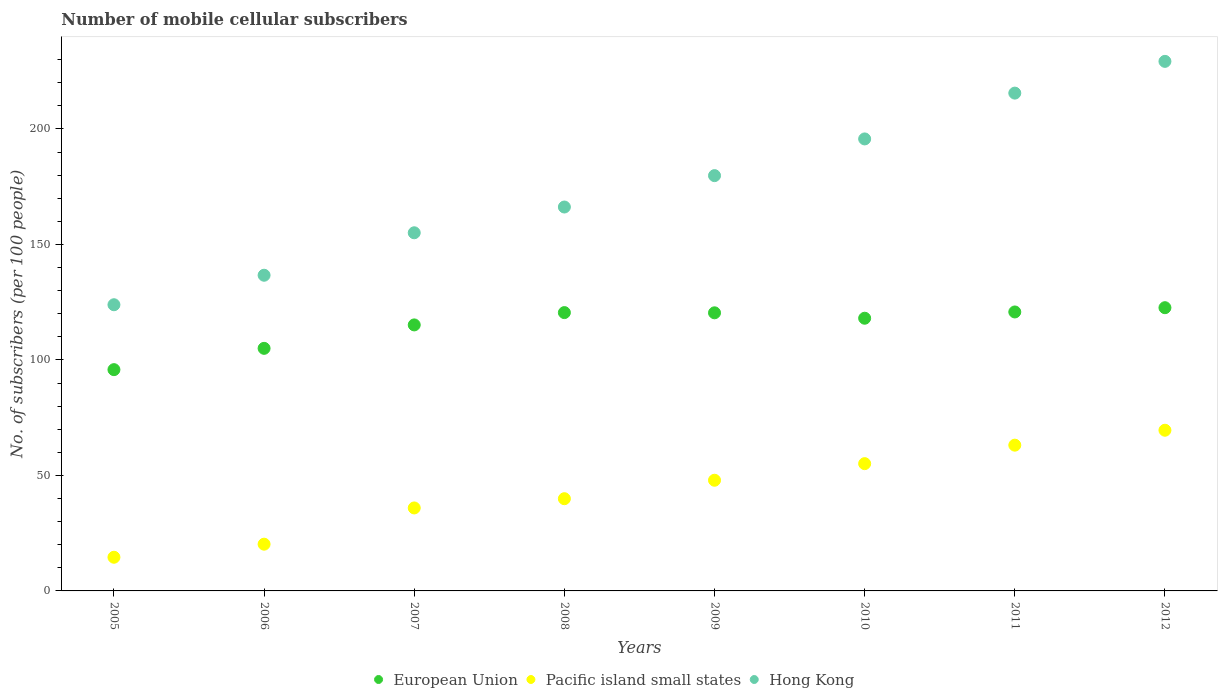Is the number of dotlines equal to the number of legend labels?
Keep it short and to the point. Yes. What is the number of mobile cellular subscribers in European Union in 2005?
Give a very brief answer. 95.79. Across all years, what is the maximum number of mobile cellular subscribers in Hong Kong?
Provide a succinct answer. 229.24. Across all years, what is the minimum number of mobile cellular subscribers in Hong Kong?
Make the answer very short. 123.89. In which year was the number of mobile cellular subscribers in Hong Kong maximum?
Provide a succinct answer. 2012. What is the total number of mobile cellular subscribers in Pacific island small states in the graph?
Ensure brevity in your answer.  346.33. What is the difference between the number of mobile cellular subscribers in Pacific island small states in 2005 and that in 2012?
Your answer should be compact. -54.99. What is the difference between the number of mobile cellular subscribers in European Union in 2008 and the number of mobile cellular subscribers in Pacific island small states in 2007?
Give a very brief answer. 84.56. What is the average number of mobile cellular subscribers in Hong Kong per year?
Make the answer very short. 175.25. In the year 2008, what is the difference between the number of mobile cellular subscribers in European Union and number of mobile cellular subscribers in Hong Kong?
Your answer should be very brief. -45.71. In how many years, is the number of mobile cellular subscribers in Pacific island small states greater than 210?
Ensure brevity in your answer.  0. What is the ratio of the number of mobile cellular subscribers in Hong Kong in 2008 to that in 2010?
Offer a very short reply. 0.85. Is the number of mobile cellular subscribers in European Union in 2006 less than that in 2012?
Offer a terse response. Yes. Is the difference between the number of mobile cellular subscribers in European Union in 2009 and 2012 greater than the difference between the number of mobile cellular subscribers in Hong Kong in 2009 and 2012?
Your answer should be very brief. Yes. What is the difference between the highest and the second highest number of mobile cellular subscribers in Pacific island small states?
Offer a very short reply. 6.46. What is the difference between the highest and the lowest number of mobile cellular subscribers in Hong Kong?
Keep it short and to the point. 105.36. In how many years, is the number of mobile cellular subscribers in European Union greater than the average number of mobile cellular subscribers in European Union taken over all years?
Provide a succinct answer. 6. Is the sum of the number of mobile cellular subscribers in Hong Kong in 2006 and 2008 greater than the maximum number of mobile cellular subscribers in Pacific island small states across all years?
Keep it short and to the point. Yes. Is the number of mobile cellular subscribers in Pacific island small states strictly less than the number of mobile cellular subscribers in European Union over the years?
Keep it short and to the point. Yes. How many dotlines are there?
Give a very brief answer. 3. What is the difference between two consecutive major ticks on the Y-axis?
Keep it short and to the point. 50. Does the graph contain grids?
Your answer should be very brief. No. Where does the legend appear in the graph?
Offer a very short reply. Bottom center. How many legend labels are there?
Provide a short and direct response. 3. How are the legend labels stacked?
Provide a succinct answer. Horizontal. What is the title of the graph?
Your answer should be compact. Number of mobile cellular subscribers. What is the label or title of the X-axis?
Keep it short and to the point. Years. What is the label or title of the Y-axis?
Provide a short and direct response. No. of subscribers (per 100 people). What is the No. of subscribers (per 100 people) of European Union in 2005?
Your answer should be very brief. 95.79. What is the No. of subscribers (per 100 people) of Pacific island small states in 2005?
Offer a terse response. 14.58. What is the No. of subscribers (per 100 people) in Hong Kong in 2005?
Provide a short and direct response. 123.89. What is the No. of subscribers (per 100 people) in European Union in 2006?
Your answer should be very brief. 105.01. What is the No. of subscribers (per 100 people) in Pacific island small states in 2006?
Give a very brief answer. 20.23. What is the No. of subscribers (per 100 people) of Hong Kong in 2006?
Provide a succinct answer. 136.66. What is the No. of subscribers (per 100 people) of European Union in 2007?
Your response must be concise. 115.16. What is the No. of subscribers (per 100 people) of Pacific island small states in 2007?
Your answer should be very brief. 35.92. What is the No. of subscribers (per 100 people) in Hong Kong in 2007?
Provide a succinct answer. 155.04. What is the No. of subscribers (per 100 people) in European Union in 2008?
Ensure brevity in your answer.  120.48. What is the No. of subscribers (per 100 people) in Pacific island small states in 2008?
Make the answer very short. 39.92. What is the No. of subscribers (per 100 people) of Hong Kong in 2008?
Your answer should be compact. 166.19. What is the No. of subscribers (per 100 people) in European Union in 2009?
Ensure brevity in your answer.  120.39. What is the No. of subscribers (per 100 people) in Pacific island small states in 2009?
Ensure brevity in your answer.  47.92. What is the No. of subscribers (per 100 people) of Hong Kong in 2009?
Your answer should be compact. 179.78. What is the No. of subscribers (per 100 people) in European Union in 2010?
Keep it short and to the point. 118.05. What is the No. of subscribers (per 100 people) of Pacific island small states in 2010?
Give a very brief answer. 55.1. What is the No. of subscribers (per 100 people) of Hong Kong in 2010?
Your response must be concise. 195.67. What is the No. of subscribers (per 100 people) in European Union in 2011?
Ensure brevity in your answer.  120.76. What is the No. of subscribers (per 100 people) in Pacific island small states in 2011?
Keep it short and to the point. 63.1. What is the No. of subscribers (per 100 people) in Hong Kong in 2011?
Make the answer very short. 215.5. What is the No. of subscribers (per 100 people) in European Union in 2012?
Your response must be concise. 122.61. What is the No. of subscribers (per 100 people) of Pacific island small states in 2012?
Provide a succinct answer. 69.56. What is the No. of subscribers (per 100 people) of Hong Kong in 2012?
Ensure brevity in your answer.  229.24. Across all years, what is the maximum No. of subscribers (per 100 people) in European Union?
Provide a succinct answer. 122.61. Across all years, what is the maximum No. of subscribers (per 100 people) of Pacific island small states?
Provide a succinct answer. 69.56. Across all years, what is the maximum No. of subscribers (per 100 people) in Hong Kong?
Give a very brief answer. 229.24. Across all years, what is the minimum No. of subscribers (per 100 people) in European Union?
Provide a short and direct response. 95.79. Across all years, what is the minimum No. of subscribers (per 100 people) in Pacific island small states?
Ensure brevity in your answer.  14.58. Across all years, what is the minimum No. of subscribers (per 100 people) in Hong Kong?
Ensure brevity in your answer.  123.89. What is the total No. of subscribers (per 100 people) of European Union in the graph?
Give a very brief answer. 918.26. What is the total No. of subscribers (per 100 people) in Pacific island small states in the graph?
Your answer should be very brief. 346.33. What is the total No. of subscribers (per 100 people) in Hong Kong in the graph?
Offer a very short reply. 1401.98. What is the difference between the No. of subscribers (per 100 people) in European Union in 2005 and that in 2006?
Provide a short and direct response. -9.22. What is the difference between the No. of subscribers (per 100 people) of Pacific island small states in 2005 and that in 2006?
Offer a very short reply. -5.66. What is the difference between the No. of subscribers (per 100 people) of Hong Kong in 2005 and that in 2006?
Make the answer very short. -12.77. What is the difference between the No. of subscribers (per 100 people) of European Union in 2005 and that in 2007?
Provide a short and direct response. -19.36. What is the difference between the No. of subscribers (per 100 people) in Pacific island small states in 2005 and that in 2007?
Keep it short and to the point. -21.35. What is the difference between the No. of subscribers (per 100 people) in Hong Kong in 2005 and that in 2007?
Make the answer very short. -31.15. What is the difference between the No. of subscribers (per 100 people) in European Union in 2005 and that in 2008?
Provide a short and direct response. -24.69. What is the difference between the No. of subscribers (per 100 people) of Pacific island small states in 2005 and that in 2008?
Your answer should be compact. -25.35. What is the difference between the No. of subscribers (per 100 people) in Hong Kong in 2005 and that in 2008?
Make the answer very short. -42.3. What is the difference between the No. of subscribers (per 100 people) of European Union in 2005 and that in 2009?
Offer a very short reply. -24.6. What is the difference between the No. of subscribers (per 100 people) in Pacific island small states in 2005 and that in 2009?
Offer a terse response. -33.34. What is the difference between the No. of subscribers (per 100 people) of Hong Kong in 2005 and that in 2009?
Make the answer very short. -55.89. What is the difference between the No. of subscribers (per 100 people) in European Union in 2005 and that in 2010?
Your answer should be compact. -22.26. What is the difference between the No. of subscribers (per 100 people) of Pacific island small states in 2005 and that in 2010?
Your answer should be compact. -40.52. What is the difference between the No. of subscribers (per 100 people) in Hong Kong in 2005 and that in 2010?
Your response must be concise. -71.78. What is the difference between the No. of subscribers (per 100 people) of European Union in 2005 and that in 2011?
Offer a terse response. -24.97. What is the difference between the No. of subscribers (per 100 people) in Pacific island small states in 2005 and that in 2011?
Your answer should be compact. -48.53. What is the difference between the No. of subscribers (per 100 people) of Hong Kong in 2005 and that in 2011?
Your answer should be very brief. -91.61. What is the difference between the No. of subscribers (per 100 people) in European Union in 2005 and that in 2012?
Offer a very short reply. -26.82. What is the difference between the No. of subscribers (per 100 people) of Pacific island small states in 2005 and that in 2012?
Your answer should be compact. -54.99. What is the difference between the No. of subscribers (per 100 people) in Hong Kong in 2005 and that in 2012?
Your response must be concise. -105.36. What is the difference between the No. of subscribers (per 100 people) in European Union in 2006 and that in 2007?
Offer a terse response. -10.14. What is the difference between the No. of subscribers (per 100 people) in Pacific island small states in 2006 and that in 2007?
Offer a very short reply. -15.69. What is the difference between the No. of subscribers (per 100 people) in Hong Kong in 2006 and that in 2007?
Provide a short and direct response. -18.38. What is the difference between the No. of subscribers (per 100 people) of European Union in 2006 and that in 2008?
Keep it short and to the point. -15.47. What is the difference between the No. of subscribers (per 100 people) of Pacific island small states in 2006 and that in 2008?
Give a very brief answer. -19.69. What is the difference between the No. of subscribers (per 100 people) of Hong Kong in 2006 and that in 2008?
Keep it short and to the point. -29.53. What is the difference between the No. of subscribers (per 100 people) in European Union in 2006 and that in 2009?
Offer a very short reply. -15.38. What is the difference between the No. of subscribers (per 100 people) in Pacific island small states in 2006 and that in 2009?
Offer a very short reply. -27.68. What is the difference between the No. of subscribers (per 100 people) of Hong Kong in 2006 and that in 2009?
Make the answer very short. -43.12. What is the difference between the No. of subscribers (per 100 people) of European Union in 2006 and that in 2010?
Give a very brief answer. -13.04. What is the difference between the No. of subscribers (per 100 people) of Pacific island small states in 2006 and that in 2010?
Keep it short and to the point. -34.86. What is the difference between the No. of subscribers (per 100 people) of Hong Kong in 2006 and that in 2010?
Make the answer very short. -59.01. What is the difference between the No. of subscribers (per 100 people) in European Union in 2006 and that in 2011?
Keep it short and to the point. -15.75. What is the difference between the No. of subscribers (per 100 people) in Pacific island small states in 2006 and that in 2011?
Ensure brevity in your answer.  -42.87. What is the difference between the No. of subscribers (per 100 people) in Hong Kong in 2006 and that in 2011?
Make the answer very short. -78.84. What is the difference between the No. of subscribers (per 100 people) of European Union in 2006 and that in 2012?
Your answer should be compact. -17.6. What is the difference between the No. of subscribers (per 100 people) of Pacific island small states in 2006 and that in 2012?
Provide a short and direct response. -49.33. What is the difference between the No. of subscribers (per 100 people) of Hong Kong in 2006 and that in 2012?
Provide a succinct answer. -92.58. What is the difference between the No. of subscribers (per 100 people) of European Union in 2007 and that in 2008?
Your answer should be very brief. -5.33. What is the difference between the No. of subscribers (per 100 people) in Pacific island small states in 2007 and that in 2008?
Make the answer very short. -4. What is the difference between the No. of subscribers (per 100 people) in Hong Kong in 2007 and that in 2008?
Your answer should be compact. -11.15. What is the difference between the No. of subscribers (per 100 people) in European Union in 2007 and that in 2009?
Your response must be concise. -5.24. What is the difference between the No. of subscribers (per 100 people) of Pacific island small states in 2007 and that in 2009?
Keep it short and to the point. -11.99. What is the difference between the No. of subscribers (per 100 people) in Hong Kong in 2007 and that in 2009?
Provide a succinct answer. -24.74. What is the difference between the No. of subscribers (per 100 people) of European Union in 2007 and that in 2010?
Keep it short and to the point. -2.89. What is the difference between the No. of subscribers (per 100 people) in Pacific island small states in 2007 and that in 2010?
Your answer should be very brief. -19.18. What is the difference between the No. of subscribers (per 100 people) in Hong Kong in 2007 and that in 2010?
Offer a very short reply. -40.63. What is the difference between the No. of subscribers (per 100 people) of European Union in 2007 and that in 2011?
Your answer should be compact. -5.61. What is the difference between the No. of subscribers (per 100 people) of Pacific island small states in 2007 and that in 2011?
Ensure brevity in your answer.  -27.18. What is the difference between the No. of subscribers (per 100 people) of Hong Kong in 2007 and that in 2011?
Provide a short and direct response. -60.46. What is the difference between the No. of subscribers (per 100 people) of European Union in 2007 and that in 2012?
Your answer should be very brief. -7.45. What is the difference between the No. of subscribers (per 100 people) in Pacific island small states in 2007 and that in 2012?
Offer a very short reply. -33.64. What is the difference between the No. of subscribers (per 100 people) of Hong Kong in 2007 and that in 2012?
Offer a very short reply. -74.2. What is the difference between the No. of subscribers (per 100 people) in European Union in 2008 and that in 2009?
Offer a very short reply. 0.09. What is the difference between the No. of subscribers (per 100 people) of Pacific island small states in 2008 and that in 2009?
Provide a succinct answer. -7.99. What is the difference between the No. of subscribers (per 100 people) in Hong Kong in 2008 and that in 2009?
Make the answer very short. -13.59. What is the difference between the No. of subscribers (per 100 people) in European Union in 2008 and that in 2010?
Make the answer very short. 2.44. What is the difference between the No. of subscribers (per 100 people) in Pacific island small states in 2008 and that in 2010?
Your answer should be compact. -15.18. What is the difference between the No. of subscribers (per 100 people) in Hong Kong in 2008 and that in 2010?
Keep it short and to the point. -29.48. What is the difference between the No. of subscribers (per 100 people) in European Union in 2008 and that in 2011?
Make the answer very short. -0.28. What is the difference between the No. of subscribers (per 100 people) in Pacific island small states in 2008 and that in 2011?
Ensure brevity in your answer.  -23.18. What is the difference between the No. of subscribers (per 100 people) in Hong Kong in 2008 and that in 2011?
Ensure brevity in your answer.  -49.31. What is the difference between the No. of subscribers (per 100 people) in European Union in 2008 and that in 2012?
Give a very brief answer. -2.13. What is the difference between the No. of subscribers (per 100 people) of Pacific island small states in 2008 and that in 2012?
Offer a terse response. -29.64. What is the difference between the No. of subscribers (per 100 people) of Hong Kong in 2008 and that in 2012?
Your answer should be very brief. -63.05. What is the difference between the No. of subscribers (per 100 people) of European Union in 2009 and that in 2010?
Give a very brief answer. 2.34. What is the difference between the No. of subscribers (per 100 people) in Pacific island small states in 2009 and that in 2010?
Keep it short and to the point. -7.18. What is the difference between the No. of subscribers (per 100 people) of Hong Kong in 2009 and that in 2010?
Offer a very short reply. -15.89. What is the difference between the No. of subscribers (per 100 people) in European Union in 2009 and that in 2011?
Give a very brief answer. -0.37. What is the difference between the No. of subscribers (per 100 people) in Pacific island small states in 2009 and that in 2011?
Ensure brevity in your answer.  -15.19. What is the difference between the No. of subscribers (per 100 people) in Hong Kong in 2009 and that in 2011?
Provide a short and direct response. -35.72. What is the difference between the No. of subscribers (per 100 people) in European Union in 2009 and that in 2012?
Your answer should be very brief. -2.22. What is the difference between the No. of subscribers (per 100 people) in Pacific island small states in 2009 and that in 2012?
Your response must be concise. -21.65. What is the difference between the No. of subscribers (per 100 people) in Hong Kong in 2009 and that in 2012?
Keep it short and to the point. -49.46. What is the difference between the No. of subscribers (per 100 people) of European Union in 2010 and that in 2011?
Make the answer very short. -2.72. What is the difference between the No. of subscribers (per 100 people) in Pacific island small states in 2010 and that in 2011?
Give a very brief answer. -8. What is the difference between the No. of subscribers (per 100 people) of Hong Kong in 2010 and that in 2011?
Offer a very short reply. -19.83. What is the difference between the No. of subscribers (per 100 people) of European Union in 2010 and that in 2012?
Offer a terse response. -4.56. What is the difference between the No. of subscribers (per 100 people) in Pacific island small states in 2010 and that in 2012?
Your response must be concise. -14.46. What is the difference between the No. of subscribers (per 100 people) of Hong Kong in 2010 and that in 2012?
Your answer should be compact. -33.58. What is the difference between the No. of subscribers (per 100 people) in European Union in 2011 and that in 2012?
Ensure brevity in your answer.  -1.85. What is the difference between the No. of subscribers (per 100 people) of Pacific island small states in 2011 and that in 2012?
Ensure brevity in your answer.  -6.46. What is the difference between the No. of subscribers (per 100 people) in Hong Kong in 2011 and that in 2012?
Keep it short and to the point. -13.74. What is the difference between the No. of subscribers (per 100 people) of European Union in 2005 and the No. of subscribers (per 100 people) of Pacific island small states in 2006?
Keep it short and to the point. 75.56. What is the difference between the No. of subscribers (per 100 people) in European Union in 2005 and the No. of subscribers (per 100 people) in Hong Kong in 2006?
Your answer should be compact. -40.87. What is the difference between the No. of subscribers (per 100 people) in Pacific island small states in 2005 and the No. of subscribers (per 100 people) in Hong Kong in 2006?
Give a very brief answer. -122.08. What is the difference between the No. of subscribers (per 100 people) in European Union in 2005 and the No. of subscribers (per 100 people) in Pacific island small states in 2007?
Provide a succinct answer. 59.87. What is the difference between the No. of subscribers (per 100 people) of European Union in 2005 and the No. of subscribers (per 100 people) of Hong Kong in 2007?
Provide a succinct answer. -59.25. What is the difference between the No. of subscribers (per 100 people) of Pacific island small states in 2005 and the No. of subscribers (per 100 people) of Hong Kong in 2007?
Keep it short and to the point. -140.46. What is the difference between the No. of subscribers (per 100 people) of European Union in 2005 and the No. of subscribers (per 100 people) of Pacific island small states in 2008?
Offer a terse response. 55.87. What is the difference between the No. of subscribers (per 100 people) in European Union in 2005 and the No. of subscribers (per 100 people) in Hong Kong in 2008?
Your answer should be very brief. -70.4. What is the difference between the No. of subscribers (per 100 people) in Pacific island small states in 2005 and the No. of subscribers (per 100 people) in Hong Kong in 2008?
Provide a short and direct response. -151.62. What is the difference between the No. of subscribers (per 100 people) in European Union in 2005 and the No. of subscribers (per 100 people) in Pacific island small states in 2009?
Offer a very short reply. 47.88. What is the difference between the No. of subscribers (per 100 people) of European Union in 2005 and the No. of subscribers (per 100 people) of Hong Kong in 2009?
Your answer should be compact. -83.99. What is the difference between the No. of subscribers (per 100 people) of Pacific island small states in 2005 and the No. of subscribers (per 100 people) of Hong Kong in 2009?
Your answer should be compact. -165.21. What is the difference between the No. of subscribers (per 100 people) in European Union in 2005 and the No. of subscribers (per 100 people) in Pacific island small states in 2010?
Provide a succinct answer. 40.69. What is the difference between the No. of subscribers (per 100 people) in European Union in 2005 and the No. of subscribers (per 100 people) in Hong Kong in 2010?
Offer a very short reply. -99.88. What is the difference between the No. of subscribers (per 100 people) of Pacific island small states in 2005 and the No. of subscribers (per 100 people) of Hong Kong in 2010?
Your answer should be very brief. -181.09. What is the difference between the No. of subscribers (per 100 people) in European Union in 2005 and the No. of subscribers (per 100 people) in Pacific island small states in 2011?
Your answer should be very brief. 32.69. What is the difference between the No. of subscribers (per 100 people) in European Union in 2005 and the No. of subscribers (per 100 people) in Hong Kong in 2011?
Ensure brevity in your answer.  -119.71. What is the difference between the No. of subscribers (per 100 people) of Pacific island small states in 2005 and the No. of subscribers (per 100 people) of Hong Kong in 2011?
Your answer should be compact. -200.93. What is the difference between the No. of subscribers (per 100 people) in European Union in 2005 and the No. of subscribers (per 100 people) in Pacific island small states in 2012?
Give a very brief answer. 26.23. What is the difference between the No. of subscribers (per 100 people) of European Union in 2005 and the No. of subscribers (per 100 people) of Hong Kong in 2012?
Provide a short and direct response. -133.45. What is the difference between the No. of subscribers (per 100 people) of Pacific island small states in 2005 and the No. of subscribers (per 100 people) of Hong Kong in 2012?
Provide a short and direct response. -214.67. What is the difference between the No. of subscribers (per 100 people) of European Union in 2006 and the No. of subscribers (per 100 people) of Pacific island small states in 2007?
Keep it short and to the point. 69.09. What is the difference between the No. of subscribers (per 100 people) in European Union in 2006 and the No. of subscribers (per 100 people) in Hong Kong in 2007?
Provide a succinct answer. -50.03. What is the difference between the No. of subscribers (per 100 people) in Pacific island small states in 2006 and the No. of subscribers (per 100 people) in Hong Kong in 2007?
Your response must be concise. -134.81. What is the difference between the No. of subscribers (per 100 people) in European Union in 2006 and the No. of subscribers (per 100 people) in Pacific island small states in 2008?
Ensure brevity in your answer.  65.09. What is the difference between the No. of subscribers (per 100 people) in European Union in 2006 and the No. of subscribers (per 100 people) in Hong Kong in 2008?
Offer a terse response. -61.18. What is the difference between the No. of subscribers (per 100 people) in Pacific island small states in 2006 and the No. of subscribers (per 100 people) in Hong Kong in 2008?
Offer a terse response. -145.96. What is the difference between the No. of subscribers (per 100 people) in European Union in 2006 and the No. of subscribers (per 100 people) in Pacific island small states in 2009?
Offer a very short reply. 57.1. What is the difference between the No. of subscribers (per 100 people) in European Union in 2006 and the No. of subscribers (per 100 people) in Hong Kong in 2009?
Offer a terse response. -74.77. What is the difference between the No. of subscribers (per 100 people) in Pacific island small states in 2006 and the No. of subscribers (per 100 people) in Hong Kong in 2009?
Make the answer very short. -159.55. What is the difference between the No. of subscribers (per 100 people) of European Union in 2006 and the No. of subscribers (per 100 people) of Pacific island small states in 2010?
Give a very brief answer. 49.92. What is the difference between the No. of subscribers (per 100 people) in European Union in 2006 and the No. of subscribers (per 100 people) in Hong Kong in 2010?
Provide a short and direct response. -90.66. What is the difference between the No. of subscribers (per 100 people) in Pacific island small states in 2006 and the No. of subscribers (per 100 people) in Hong Kong in 2010?
Offer a very short reply. -175.43. What is the difference between the No. of subscribers (per 100 people) of European Union in 2006 and the No. of subscribers (per 100 people) of Pacific island small states in 2011?
Your answer should be very brief. 41.91. What is the difference between the No. of subscribers (per 100 people) of European Union in 2006 and the No. of subscribers (per 100 people) of Hong Kong in 2011?
Provide a short and direct response. -110.49. What is the difference between the No. of subscribers (per 100 people) in Pacific island small states in 2006 and the No. of subscribers (per 100 people) in Hong Kong in 2011?
Your response must be concise. -195.27. What is the difference between the No. of subscribers (per 100 people) of European Union in 2006 and the No. of subscribers (per 100 people) of Pacific island small states in 2012?
Provide a succinct answer. 35.45. What is the difference between the No. of subscribers (per 100 people) in European Union in 2006 and the No. of subscribers (per 100 people) in Hong Kong in 2012?
Offer a terse response. -124.23. What is the difference between the No. of subscribers (per 100 people) in Pacific island small states in 2006 and the No. of subscribers (per 100 people) in Hong Kong in 2012?
Ensure brevity in your answer.  -209.01. What is the difference between the No. of subscribers (per 100 people) of European Union in 2007 and the No. of subscribers (per 100 people) of Pacific island small states in 2008?
Your answer should be very brief. 75.23. What is the difference between the No. of subscribers (per 100 people) in European Union in 2007 and the No. of subscribers (per 100 people) in Hong Kong in 2008?
Your answer should be compact. -51.04. What is the difference between the No. of subscribers (per 100 people) of Pacific island small states in 2007 and the No. of subscribers (per 100 people) of Hong Kong in 2008?
Give a very brief answer. -130.27. What is the difference between the No. of subscribers (per 100 people) of European Union in 2007 and the No. of subscribers (per 100 people) of Pacific island small states in 2009?
Offer a terse response. 67.24. What is the difference between the No. of subscribers (per 100 people) in European Union in 2007 and the No. of subscribers (per 100 people) in Hong Kong in 2009?
Keep it short and to the point. -64.63. What is the difference between the No. of subscribers (per 100 people) in Pacific island small states in 2007 and the No. of subscribers (per 100 people) in Hong Kong in 2009?
Ensure brevity in your answer.  -143.86. What is the difference between the No. of subscribers (per 100 people) in European Union in 2007 and the No. of subscribers (per 100 people) in Pacific island small states in 2010?
Provide a succinct answer. 60.06. What is the difference between the No. of subscribers (per 100 people) of European Union in 2007 and the No. of subscribers (per 100 people) of Hong Kong in 2010?
Provide a succinct answer. -80.51. What is the difference between the No. of subscribers (per 100 people) in Pacific island small states in 2007 and the No. of subscribers (per 100 people) in Hong Kong in 2010?
Make the answer very short. -159.75. What is the difference between the No. of subscribers (per 100 people) of European Union in 2007 and the No. of subscribers (per 100 people) of Pacific island small states in 2011?
Provide a succinct answer. 52.06. What is the difference between the No. of subscribers (per 100 people) in European Union in 2007 and the No. of subscribers (per 100 people) in Hong Kong in 2011?
Provide a short and direct response. -100.35. What is the difference between the No. of subscribers (per 100 people) in Pacific island small states in 2007 and the No. of subscribers (per 100 people) in Hong Kong in 2011?
Keep it short and to the point. -179.58. What is the difference between the No. of subscribers (per 100 people) in European Union in 2007 and the No. of subscribers (per 100 people) in Pacific island small states in 2012?
Offer a very short reply. 45.59. What is the difference between the No. of subscribers (per 100 people) of European Union in 2007 and the No. of subscribers (per 100 people) of Hong Kong in 2012?
Your answer should be compact. -114.09. What is the difference between the No. of subscribers (per 100 people) of Pacific island small states in 2007 and the No. of subscribers (per 100 people) of Hong Kong in 2012?
Provide a succinct answer. -193.32. What is the difference between the No. of subscribers (per 100 people) in European Union in 2008 and the No. of subscribers (per 100 people) in Pacific island small states in 2009?
Your answer should be very brief. 72.57. What is the difference between the No. of subscribers (per 100 people) of European Union in 2008 and the No. of subscribers (per 100 people) of Hong Kong in 2009?
Make the answer very short. -59.3. What is the difference between the No. of subscribers (per 100 people) of Pacific island small states in 2008 and the No. of subscribers (per 100 people) of Hong Kong in 2009?
Your response must be concise. -139.86. What is the difference between the No. of subscribers (per 100 people) of European Union in 2008 and the No. of subscribers (per 100 people) of Pacific island small states in 2010?
Provide a short and direct response. 65.39. What is the difference between the No. of subscribers (per 100 people) of European Union in 2008 and the No. of subscribers (per 100 people) of Hong Kong in 2010?
Your response must be concise. -75.19. What is the difference between the No. of subscribers (per 100 people) in Pacific island small states in 2008 and the No. of subscribers (per 100 people) in Hong Kong in 2010?
Your answer should be very brief. -155.75. What is the difference between the No. of subscribers (per 100 people) of European Union in 2008 and the No. of subscribers (per 100 people) of Pacific island small states in 2011?
Give a very brief answer. 57.38. What is the difference between the No. of subscribers (per 100 people) in European Union in 2008 and the No. of subscribers (per 100 people) in Hong Kong in 2011?
Offer a very short reply. -95.02. What is the difference between the No. of subscribers (per 100 people) in Pacific island small states in 2008 and the No. of subscribers (per 100 people) in Hong Kong in 2011?
Offer a very short reply. -175.58. What is the difference between the No. of subscribers (per 100 people) in European Union in 2008 and the No. of subscribers (per 100 people) in Pacific island small states in 2012?
Make the answer very short. 50.92. What is the difference between the No. of subscribers (per 100 people) of European Union in 2008 and the No. of subscribers (per 100 people) of Hong Kong in 2012?
Provide a short and direct response. -108.76. What is the difference between the No. of subscribers (per 100 people) of Pacific island small states in 2008 and the No. of subscribers (per 100 people) of Hong Kong in 2012?
Keep it short and to the point. -189.32. What is the difference between the No. of subscribers (per 100 people) of European Union in 2009 and the No. of subscribers (per 100 people) of Pacific island small states in 2010?
Provide a short and direct response. 65.3. What is the difference between the No. of subscribers (per 100 people) in European Union in 2009 and the No. of subscribers (per 100 people) in Hong Kong in 2010?
Offer a terse response. -75.28. What is the difference between the No. of subscribers (per 100 people) of Pacific island small states in 2009 and the No. of subscribers (per 100 people) of Hong Kong in 2010?
Your answer should be compact. -147.75. What is the difference between the No. of subscribers (per 100 people) in European Union in 2009 and the No. of subscribers (per 100 people) in Pacific island small states in 2011?
Keep it short and to the point. 57.29. What is the difference between the No. of subscribers (per 100 people) of European Union in 2009 and the No. of subscribers (per 100 people) of Hong Kong in 2011?
Give a very brief answer. -95.11. What is the difference between the No. of subscribers (per 100 people) in Pacific island small states in 2009 and the No. of subscribers (per 100 people) in Hong Kong in 2011?
Provide a short and direct response. -167.59. What is the difference between the No. of subscribers (per 100 people) of European Union in 2009 and the No. of subscribers (per 100 people) of Pacific island small states in 2012?
Your response must be concise. 50.83. What is the difference between the No. of subscribers (per 100 people) in European Union in 2009 and the No. of subscribers (per 100 people) in Hong Kong in 2012?
Ensure brevity in your answer.  -108.85. What is the difference between the No. of subscribers (per 100 people) of Pacific island small states in 2009 and the No. of subscribers (per 100 people) of Hong Kong in 2012?
Provide a short and direct response. -181.33. What is the difference between the No. of subscribers (per 100 people) in European Union in 2010 and the No. of subscribers (per 100 people) in Pacific island small states in 2011?
Provide a short and direct response. 54.95. What is the difference between the No. of subscribers (per 100 people) in European Union in 2010 and the No. of subscribers (per 100 people) in Hong Kong in 2011?
Your answer should be compact. -97.46. What is the difference between the No. of subscribers (per 100 people) of Pacific island small states in 2010 and the No. of subscribers (per 100 people) of Hong Kong in 2011?
Offer a very short reply. -160.41. What is the difference between the No. of subscribers (per 100 people) in European Union in 2010 and the No. of subscribers (per 100 people) in Pacific island small states in 2012?
Make the answer very short. 48.49. What is the difference between the No. of subscribers (per 100 people) in European Union in 2010 and the No. of subscribers (per 100 people) in Hong Kong in 2012?
Provide a succinct answer. -111.2. What is the difference between the No. of subscribers (per 100 people) in Pacific island small states in 2010 and the No. of subscribers (per 100 people) in Hong Kong in 2012?
Provide a succinct answer. -174.15. What is the difference between the No. of subscribers (per 100 people) in European Union in 2011 and the No. of subscribers (per 100 people) in Pacific island small states in 2012?
Your answer should be very brief. 51.2. What is the difference between the No. of subscribers (per 100 people) of European Union in 2011 and the No. of subscribers (per 100 people) of Hong Kong in 2012?
Make the answer very short. -108.48. What is the difference between the No. of subscribers (per 100 people) in Pacific island small states in 2011 and the No. of subscribers (per 100 people) in Hong Kong in 2012?
Your response must be concise. -166.14. What is the average No. of subscribers (per 100 people) in European Union per year?
Keep it short and to the point. 114.78. What is the average No. of subscribers (per 100 people) of Pacific island small states per year?
Offer a terse response. 43.29. What is the average No. of subscribers (per 100 people) of Hong Kong per year?
Your response must be concise. 175.25. In the year 2005, what is the difference between the No. of subscribers (per 100 people) in European Union and No. of subscribers (per 100 people) in Pacific island small states?
Your answer should be very brief. 81.22. In the year 2005, what is the difference between the No. of subscribers (per 100 people) of European Union and No. of subscribers (per 100 people) of Hong Kong?
Your response must be concise. -28.1. In the year 2005, what is the difference between the No. of subscribers (per 100 people) of Pacific island small states and No. of subscribers (per 100 people) of Hong Kong?
Keep it short and to the point. -109.31. In the year 2006, what is the difference between the No. of subscribers (per 100 people) in European Union and No. of subscribers (per 100 people) in Pacific island small states?
Your response must be concise. 84.78. In the year 2006, what is the difference between the No. of subscribers (per 100 people) in European Union and No. of subscribers (per 100 people) in Hong Kong?
Provide a short and direct response. -31.65. In the year 2006, what is the difference between the No. of subscribers (per 100 people) in Pacific island small states and No. of subscribers (per 100 people) in Hong Kong?
Your response must be concise. -116.43. In the year 2007, what is the difference between the No. of subscribers (per 100 people) of European Union and No. of subscribers (per 100 people) of Pacific island small states?
Your answer should be very brief. 79.23. In the year 2007, what is the difference between the No. of subscribers (per 100 people) of European Union and No. of subscribers (per 100 people) of Hong Kong?
Provide a short and direct response. -39.88. In the year 2007, what is the difference between the No. of subscribers (per 100 people) in Pacific island small states and No. of subscribers (per 100 people) in Hong Kong?
Make the answer very short. -119.12. In the year 2008, what is the difference between the No. of subscribers (per 100 people) in European Union and No. of subscribers (per 100 people) in Pacific island small states?
Offer a very short reply. 80.56. In the year 2008, what is the difference between the No. of subscribers (per 100 people) of European Union and No. of subscribers (per 100 people) of Hong Kong?
Make the answer very short. -45.71. In the year 2008, what is the difference between the No. of subscribers (per 100 people) of Pacific island small states and No. of subscribers (per 100 people) of Hong Kong?
Make the answer very short. -126.27. In the year 2009, what is the difference between the No. of subscribers (per 100 people) of European Union and No. of subscribers (per 100 people) of Pacific island small states?
Your response must be concise. 72.48. In the year 2009, what is the difference between the No. of subscribers (per 100 people) of European Union and No. of subscribers (per 100 people) of Hong Kong?
Offer a terse response. -59.39. In the year 2009, what is the difference between the No. of subscribers (per 100 people) of Pacific island small states and No. of subscribers (per 100 people) of Hong Kong?
Offer a terse response. -131.87. In the year 2010, what is the difference between the No. of subscribers (per 100 people) of European Union and No. of subscribers (per 100 people) of Pacific island small states?
Keep it short and to the point. 62.95. In the year 2010, what is the difference between the No. of subscribers (per 100 people) in European Union and No. of subscribers (per 100 people) in Hong Kong?
Offer a very short reply. -77.62. In the year 2010, what is the difference between the No. of subscribers (per 100 people) of Pacific island small states and No. of subscribers (per 100 people) of Hong Kong?
Provide a succinct answer. -140.57. In the year 2011, what is the difference between the No. of subscribers (per 100 people) of European Union and No. of subscribers (per 100 people) of Pacific island small states?
Make the answer very short. 57.66. In the year 2011, what is the difference between the No. of subscribers (per 100 people) in European Union and No. of subscribers (per 100 people) in Hong Kong?
Ensure brevity in your answer.  -94.74. In the year 2011, what is the difference between the No. of subscribers (per 100 people) of Pacific island small states and No. of subscribers (per 100 people) of Hong Kong?
Your answer should be very brief. -152.4. In the year 2012, what is the difference between the No. of subscribers (per 100 people) in European Union and No. of subscribers (per 100 people) in Pacific island small states?
Provide a succinct answer. 53.05. In the year 2012, what is the difference between the No. of subscribers (per 100 people) in European Union and No. of subscribers (per 100 people) in Hong Kong?
Provide a short and direct response. -106.63. In the year 2012, what is the difference between the No. of subscribers (per 100 people) in Pacific island small states and No. of subscribers (per 100 people) in Hong Kong?
Offer a terse response. -159.68. What is the ratio of the No. of subscribers (per 100 people) of European Union in 2005 to that in 2006?
Keep it short and to the point. 0.91. What is the ratio of the No. of subscribers (per 100 people) in Pacific island small states in 2005 to that in 2006?
Give a very brief answer. 0.72. What is the ratio of the No. of subscribers (per 100 people) in Hong Kong in 2005 to that in 2006?
Your response must be concise. 0.91. What is the ratio of the No. of subscribers (per 100 people) in European Union in 2005 to that in 2007?
Your response must be concise. 0.83. What is the ratio of the No. of subscribers (per 100 people) of Pacific island small states in 2005 to that in 2007?
Provide a short and direct response. 0.41. What is the ratio of the No. of subscribers (per 100 people) in Hong Kong in 2005 to that in 2007?
Your answer should be very brief. 0.8. What is the ratio of the No. of subscribers (per 100 people) of European Union in 2005 to that in 2008?
Make the answer very short. 0.8. What is the ratio of the No. of subscribers (per 100 people) of Pacific island small states in 2005 to that in 2008?
Your answer should be compact. 0.37. What is the ratio of the No. of subscribers (per 100 people) of Hong Kong in 2005 to that in 2008?
Offer a very short reply. 0.75. What is the ratio of the No. of subscribers (per 100 people) in European Union in 2005 to that in 2009?
Keep it short and to the point. 0.8. What is the ratio of the No. of subscribers (per 100 people) of Pacific island small states in 2005 to that in 2009?
Your answer should be very brief. 0.3. What is the ratio of the No. of subscribers (per 100 people) of Hong Kong in 2005 to that in 2009?
Offer a terse response. 0.69. What is the ratio of the No. of subscribers (per 100 people) in European Union in 2005 to that in 2010?
Provide a succinct answer. 0.81. What is the ratio of the No. of subscribers (per 100 people) in Pacific island small states in 2005 to that in 2010?
Your answer should be very brief. 0.26. What is the ratio of the No. of subscribers (per 100 people) in Hong Kong in 2005 to that in 2010?
Keep it short and to the point. 0.63. What is the ratio of the No. of subscribers (per 100 people) of European Union in 2005 to that in 2011?
Your answer should be compact. 0.79. What is the ratio of the No. of subscribers (per 100 people) of Pacific island small states in 2005 to that in 2011?
Give a very brief answer. 0.23. What is the ratio of the No. of subscribers (per 100 people) in Hong Kong in 2005 to that in 2011?
Provide a short and direct response. 0.57. What is the ratio of the No. of subscribers (per 100 people) of European Union in 2005 to that in 2012?
Your response must be concise. 0.78. What is the ratio of the No. of subscribers (per 100 people) of Pacific island small states in 2005 to that in 2012?
Your response must be concise. 0.21. What is the ratio of the No. of subscribers (per 100 people) of Hong Kong in 2005 to that in 2012?
Provide a short and direct response. 0.54. What is the ratio of the No. of subscribers (per 100 people) of European Union in 2006 to that in 2007?
Offer a very short reply. 0.91. What is the ratio of the No. of subscribers (per 100 people) of Pacific island small states in 2006 to that in 2007?
Give a very brief answer. 0.56. What is the ratio of the No. of subscribers (per 100 people) of Hong Kong in 2006 to that in 2007?
Ensure brevity in your answer.  0.88. What is the ratio of the No. of subscribers (per 100 people) in European Union in 2006 to that in 2008?
Offer a terse response. 0.87. What is the ratio of the No. of subscribers (per 100 people) in Pacific island small states in 2006 to that in 2008?
Your response must be concise. 0.51. What is the ratio of the No. of subscribers (per 100 people) in Hong Kong in 2006 to that in 2008?
Offer a very short reply. 0.82. What is the ratio of the No. of subscribers (per 100 people) of European Union in 2006 to that in 2009?
Make the answer very short. 0.87. What is the ratio of the No. of subscribers (per 100 people) in Pacific island small states in 2006 to that in 2009?
Offer a terse response. 0.42. What is the ratio of the No. of subscribers (per 100 people) of Hong Kong in 2006 to that in 2009?
Keep it short and to the point. 0.76. What is the ratio of the No. of subscribers (per 100 people) of European Union in 2006 to that in 2010?
Offer a very short reply. 0.89. What is the ratio of the No. of subscribers (per 100 people) of Pacific island small states in 2006 to that in 2010?
Offer a very short reply. 0.37. What is the ratio of the No. of subscribers (per 100 people) of Hong Kong in 2006 to that in 2010?
Provide a succinct answer. 0.7. What is the ratio of the No. of subscribers (per 100 people) in European Union in 2006 to that in 2011?
Provide a succinct answer. 0.87. What is the ratio of the No. of subscribers (per 100 people) in Pacific island small states in 2006 to that in 2011?
Keep it short and to the point. 0.32. What is the ratio of the No. of subscribers (per 100 people) of Hong Kong in 2006 to that in 2011?
Keep it short and to the point. 0.63. What is the ratio of the No. of subscribers (per 100 people) in European Union in 2006 to that in 2012?
Your answer should be compact. 0.86. What is the ratio of the No. of subscribers (per 100 people) of Pacific island small states in 2006 to that in 2012?
Give a very brief answer. 0.29. What is the ratio of the No. of subscribers (per 100 people) in Hong Kong in 2006 to that in 2012?
Ensure brevity in your answer.  0.6. What is the ratio of the No. of subscribers (per 100 people) in European Union in 2007 to that in 2008?
Make the answer very short. 0.96. What is the ratio of the No. of subscribers (per 100 people) of Pacific island small states in 2007 to that in 2008?
Ensure brevity in your answer.  0.9. What is the ratio of the No. of subscribers (per 100 people) in Hong Kong in 2007 to that in 2008?
Ensure brevity in your answer.  0.93. What is the ratio of the No. of subscribers (per 100 people) in European Union in 2007 to that in 2009?
Your answer should be compact. 0.96. What is the ratio of the No. of subscribers (per 100 people) of Pacific island small states in 2007 to that in 2009?
Your answer should be compact. 0.75. What is the ratio of the No. of subscribers (per 100 people) of Hong Kong in 2007 to that in 2009?
Keep it short and to the point. 0.86. What is the ratio of the No. of subscribers (per 100 people) in European Union in 2007 to that in 2010?
Offer a terse response. 0.98. What is the ratio of the No. of subscribers (per 100 people) of Pacific island small states in 2007 to that in 2010?
Your answer should be very brief. 0.65. What is the ratio of the No. of subscribers (per 100 people) of Hong Kong in 2007 to that in 2010?
Offer a very short reply. 0.79. What is the ratio of the No. of subscribers (per 100 people) in European Union in 2007 to that in 2011?
Your response must be concise. 0.95. What is the ratio of the No. of subscribers (per 100 people) in Pacific island small states in 2007 to that in 2011?
Your answer should be compact. 0.57. What is the ratio of the No. of subscribers (per 100 people) of Hong Kong in 2007 to that in 2011?
Ensure brevity in your answer.  0.72. What is the ratio of the No. of subscribers (per 100 people) in European Union in 2007 to that in 2012?
Give a very brief answer. 0.94. What is the ratio of the No. of subscribers (per 100 people) in Pacific island small states in 2007 to that in 2012?
Ensure brevity in your answer.  0.52. What is the ratio of the No. of subscribers (per 100 people) of Hong Kong in 2007 to that in 2012?
Provide a short and direct response. 0.68. What is the ratio of the No. of subscribers (per 100 people) in European Union in 2008 to that in 2009?
Make the answer very short. 1. What is the ratio of the No. of subscribers (per 100 people) in Pacific island small states in 2008 to that in 2009?
Your answer should be compact. 0.83. What is the ratio of the No. of subscribers (per 100 people) in Hong Kong in 2008 to that in 2009?
Provide a short and direct response. 0.92. What is the ratio of the No. of subscribers (per 100 people) in European Union in 2008 to that in 2010?
Ensure brevity in your answer.  1.02. What is the ratio of the No. of subscribers (per 100 people) in Pacific island small states in 2008 to that in 2010?
Offer a terse response. 0.72. What is the ratio of the No. of subscribers (per 100 people) of Hong Kong in 2008 to that in 2010?
Keep it short and to the point. 0.85. What is the ratio of the No. of subscribers (per 100 people) in European Union in 2008 to that in 2011?
Give a very brief answer. 1. What is the ratio of the No. of subscribers (per 100 people) of Pacific island small states in 2008 to that in 2011?
Offer a very short reply. 0.63. What is the ratio of the No. of subscribers (per 100 people) in Hong Kong in 2008 to that in 2011?
Offer a terse response. 0.77. What is the ratio of the No. of subscribers (per 100 people) of European Union in 2008 to that in 2012?
Make the answer very short. 0.98. What is the ratio of the No. of subscribers (per 100 people) of Pacific island small states in 2008 to that in 2012?
Your answer should be compact. 0.57. What is the ratio of the No. of subscribers (per 100 people) in Hong Kong in 2008 to that in 2012?
Offer a terse response. 0.72. What is the ratio of the No. of subscribers (per 100 people) of European Union in 2009 to that in 2010?
Make the answer very short. 1.02. What is the ratio of the No. of subscribers (per 100 people) of Pacific island small states in 2009 to that in 2010?
Offer a terse response. 0.87. What is the ratio of the No. of subscribers (per 100 people) in Hong Kong in 2009 to that in 2010?
Your answer should be very brief. 0.92. What is the ratio of the No. of subscribers (per 100 people) of Pacific island small states in 2009 to that in 2011?
Your answer should be very brief. 0.76. What is the ratio of the No. of subscribers (per 100 people) of Hong Kong in 2009 to that in 2011?
Make the answer very short. 0.83. What is the ratio of the No. of subscribers (per 100 people) in European Union in 2009 to that in 2012?
Provide a succinct answer. 0.98. What is the ratio of the No. of subscribers (per 100 people) in Pacific island small states in 2009 to that in 2012?
Keep it short and to the point. 0.69. What is the ratio of the No. of subscribers (per 100 people) of Hong Kong in 2009 to that in 2012?
Offer a very short reply. 0.78. What is the ratio of the No. of subscribers (per 100 people) of European Union in 2010 to that in 2011?
Keep it short and to the point. 0.98. What is the ratio of the No. of subscribers (per 100 people) in Pacific island small states in 2010 to that in 2011?
Ensure brevity in your answer.  0.87. What is the ratio of the No. of subscribers (per 100 people) of Hong Kong in 2010 to that in 2011?
Your response must be concise. 0.91. What is the ratio of the No. of subscribers (per 100 people) in European Union in 2010 to that in 2012?
Your answer should be compact. 0.96. What is the ratio of the No. of subscribers (per 100 people) in Pacific island small states in 2010 to that in 2012?
Your answer should be very brief. 0.79. What is the ratio of the No. of subscribers (per 100 people) of Hong Kong in 2010 to that in 2012?
Make the answer very short. 0.85. What is the ratio of the No. of subscribers (per 100 people) of European Union in 2011 to that in 2012?
Offer a terse response. 0.98. What is the ratio of the No. of subscribers (per 100 people) of Pacific island small states in 2011 to that in 2012?
Offer a terse response. 0.91. What is the ratio of the No. of subscribers (per 100 people) in Hong Kong in 2011 to that in 2012?
Your response must be concise. 0.94. What is the difference between the highest and the second highest No. of subscribers (per 100 people) of European Union?
Your answer should be very brief. 1.85. What is the difference between the highest and the second highest No. of subscribers (per 100 people) in Pacific island small states?
Offer a terse response. 6.46. What is the difference between the highest and the second highest No. of subscribers (per 100 people) of Hong Kong?
Make the answer very short. 13.74. What is the difference between the highest and the lowest No. of subscribers (per 100 people) of European Union?
Make the answer very short. 26.82. What is the difference between the highest and the lowest No. of subscribers (per 100 people) in Pacific island small states?
Provide a short and direct response. 54.99. What is the difference between the highest and the lowest No. of subscribers (per 100 people) in Hong Kong?
Make the answer very short. 105.36. 